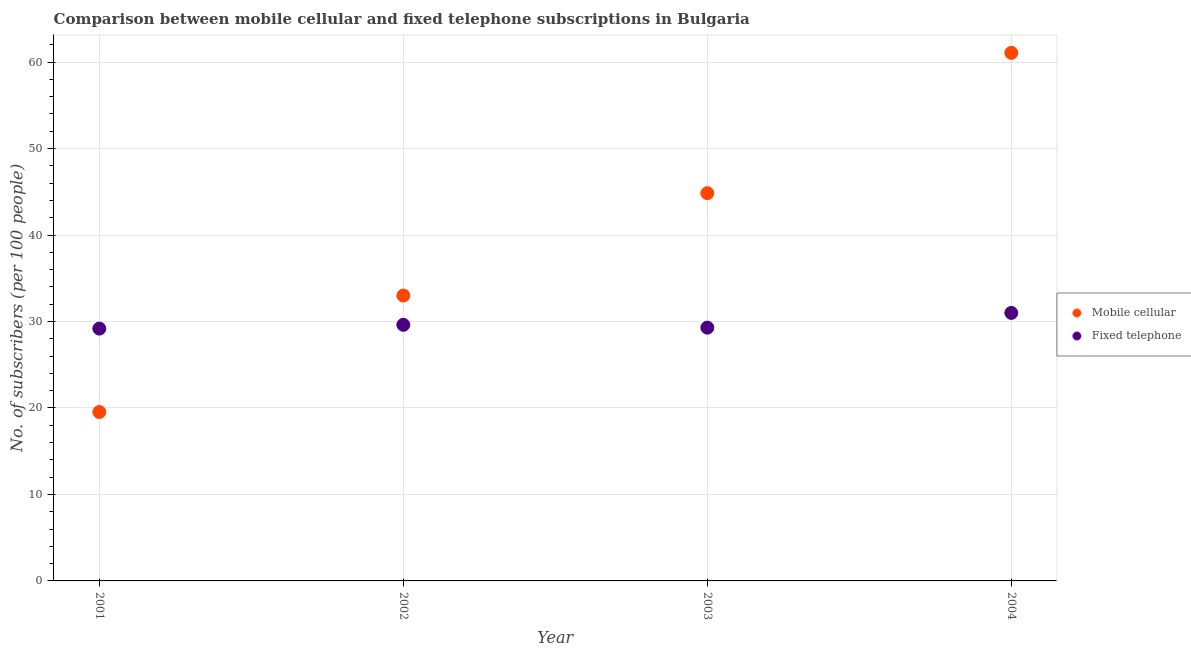How many different coloured dotlines are there?
Keep it short and to the point. 2. Is the number of dotlines equal to the number of legend labels?
Give a very brief answer. Yes. What is the number of fixed telephone subscribers in 2002?
Give a very brief answer. 29.62. Across all years, what is the maximum number of fixed telephone subscribers?
Your answer should be compact. 30.99. Across all years, what is the minimum number of mobile cellular subscribers?
Make the answer very short. 19.53. In which year was the number of mobile cellular subscribers maximum?
Provide a short and direct response. 2004. What is the total number of fixed telephone subscribers in the graph?
Give a very brief answer. 119.08. What is the difference between the number of fixed telephone subscribers in 2001 and that in 2004?
Your response must be concise. -1.81. What is the difference between the number of mobile cellular subscribers in 2002 and the number of fixed telephone subscribers in 2004?
Your answer should be very brief. 2.01. What is the average number of mobile cellular subscribers per year?
Your response must be concise. 39.61. In the year 2001, what is the difference between the number of mobile cellular subscribers and number of fixed telephone subscribers?
Provide a short and direct response. -9.65. What is the ratio of the number of fixed telephone subscribers in 2001 to that in 2003?
Keep it short and to the point. 1. Is the number of mobile cellular subscribers in 2001 less than that in 2002?
Your answer should be compact. Yes. Is the difference between the number of fixed telephone subscribers in 2003 and 2004 greater than the difference between the number of mobile cellular subscribers in 2003 and 2004?
Make the answer very short. Yes. What is the difference between the highest and the second highest number of fixed telephone subscribers?
Your answer should be compact. 1.38. What is the difference between the highest and the lowest number of mobile cellular subscribers?
Your answer should be very brief. 41.54. Is the sum of the number of fixed telephone subscribers in 2001 and 2003 greater than the maximum number of mobile cellular subscribers across all years?
Your response must be concise. No. Does the number of mobile cellular subscribers monotonically increase over the years?
Offer a terse response. Yes. Is the number of mobile cellular subscribers strictly greater than the number of fixed telephone subscribers over the years?
Keep it short and to the point. No. Is the number of mobile cellular subscribers strictly less than the number of fixed telephone subscribers over the years?
Give a very brief answer. No. What is the difference between two consecutive major ticks on the Y-axis?
Your response must be concise. 10. Does the graph contain any zero values?
Provide a succinct answer. No. Does the graph contain grids?
Your response must be concise. Yes. How many legend labels are there?
Your answer should be very brief. 2. What is the title of the graph?
Provide a short and direct response. Comparison between mobile cellular and fixed telephone subscriptions in Bulgaria. What is the label or title of the X-axis?
Your answer should be very brief. Year. What is the label or title of the Y-axis?
Give a very brief answer. No. of subscribers (per 100 people). What is the No. of subscribers (per 100 people) in Mobile cellular in 2001?
Offer a very short reply. 19.53. What is the No. of subscribers (per 100 people) in Fixed telephone in 2001?
Make the answer very short. 29.18. What is the No. of subscribers (per 100 people) of Mobile cellular in 2002?
Ensure brevity in your answer.  33. What is the No. of subscribers (per 100 people) of Fixed telephone in 2002?
Keep it short and to the point. 29.62. What is the No. of subscribers (per 100 people) of Mobile cellular in 2003?
Make the answer very short. 44.84. What is the No. of subscribers (per 100 people) in Fixed telephone in 2003?
Make the answer very short. 29.29. What is the No. of subscribers (per 100 people) in Mobile cellular in 2004?
Ensure brevity in your answer.  61.07. What is the No. of subscribers (per 100 people) in Fixed telephone in 2004?
Keep it short and to the point. 30.99. Across all years, what is the maximum No. of subscribers (per 100 people) in Mobile cellular?
Offer a terse response. 61.07. Across all years, what is the maximum No. of subscribers (per 100 people) in Fixed telephone?
Your answer should be compact. 30.99. Across all years, what is the minimum No. of subscribers (per 100 people) in Mobile cellular?
Make the answer very short. 19.53. Across all years, what is the minimum No. of subscribers (per 100 people) in Fixed telephone?
Make the answer very short. 29.18. What is the total No. of subscribers (per 100 people) in Mobile cellular in the graph?
Give a very brief answer. 158.45. What is the total No. of subscribers (per 100 people) in Fixed telephone in the graph?
Provide a short and direct response. 119.08. What is the difference between the No. of subscribers (per 100 people) in Mobile cellular in 2001 and that in 2002?
Make the answer very short. -13.47. What is the difference between the No. of subscribers (per 100 people) of Fixed telephone in 2001 and that in 2002?
Offer a very short reply. -0.44. What is the difference between the No. of subscribers (per 100 people) in Mobile cellular in 2001 and that in 2003?
Your answer should be compact. -25.31. What is the difference between the No. of subscribers (per 100 people) in Fixed telephone in 2001 and that in 2003?
Offer a terse response. -0.11. What is the difference between the No. of subscribers (per 100 people) of Mobile cellular in 2001 and that in 2004?
Offer a very short reply. -41.54. What is the difference between the No. of subscribers (per 100 people) in Fixed telephone in 2001 and that in 2004?
Your answer should be compact. -1.81. What is the difference between the No. of subscribers (per 100 people) in Mobile cellular in 2002 and that in 2003?
Offer a very short reply. -11.84. What is the difference between the No. of subscribers (per 100 people) in Fixed telephone in 2002 and that in 2003?
Keep it short and to the point. 0.33. What is the difference between the No. of subscribers (per 100 people) in Mobile cellular in 2002 and that in 2004?
Ensure brevity in your answer.  -28.07. What is the difference between the No. of subscribers (per 100 people) in Fixed telephone in 2002 and that in 2004?
Give a very brief answer. -1.38. What is the difference between the No. of subscribers (per 100 people) in Mobile cellular in 2003 and that in 2004?
Ensure brevity in your answer.  -16.23. What is the difference between the No. of subscribers (per 100 people) in Fixed telephone in 2003 and that in 2004?
Keep it short and to the point. -1.7. What is the difference between the No. of subscribers (per 100 people) in Mobile cellular in 2001 and the No. of subscribers (per 100 people) in Fixed telephone in 2002?
Your response must be concise. -10.08. What is the difference between the No. of subscribers (per 100 people) in Mobile cellular in 2001 and the No. of subscribers (per 100 people) in Fixed telephone in 2003?
Your answer should be very brief. -9.76. What is the difference between the No. of subscribers (per 100 people) of Mobile cellular in 2001 and the No. of subscribers (per 100 people) of Fixed telephone in 2004?
Your response must be concise. -11.46. What is the difference between the No. of subscribers (per 100 people) in Mobile cellular in 2002 and the No. of subscribers (per 100 people) in Fixed telephone in 2003?
Your answer should be compact. 3.71. What is the difference between the No. of subscribers (per 100 people) in Mobile cellular in 2002 and the No. of subscribers (per 100 people) in Fixed telephone in 2004?
Your response must be concise. 2.01. What is the difference between the No. of subscribers (per 100 people) in Mobile cellular in 2003 and the No. of subscribers (per 100 people) in Fixed telephone in 2004?
Keep it short and to the point. 13.85. What is the average No. of subscribers (per 100 people) in Mobile cellular per year?
Your answer should be compact. 39.61. What is the average No. of subscribers (per 100 people) of Fixed telephone per year?
Ensure brevity in your answer.  29.77. In the year 2001, what is the difference between the No. of subscribers (per 100 people) of Mobile cellular and No. of subscribers (per 100 people) of Fixed telephone?
Offer a very short reply. -9.65. In the year 2002, what is the difference between the No. of subscribers (per 100 people) in Mobile cellular and No. of subscribers (per 100 people) in Fixed telephone?
Keep it short and to the point. 3.39. In the year 2003, what is the difference between the No. of subscribers (per 100 people) in Mobile cellular and No. of subscribers (per 100 people) in Fixed telephone?
Your response must be concise. 15.55. In the year 2004, what is the difference between the No. of subscribers (per 100 people) of Mobile cellular and No. of subscribers (per 100 people) of Fixed telephone?
Provide a succinct answer. 30.08. What is the ratio of the No. of subscribers (per 100 people) of Mobile cellular in 2001 to that in 2002?
Your answer should be compact. 0.59. What is the ratio of the No. of subscribers (per 100 people) of Fixed telephone in 2001 to that in 2002?
Provide a short and direct response. 0.99. What is the ratio of the No. of subscribers (per 100 people) of Mobile cellular in 2001 to that in 2003?
Your answer should be compact. 0.44. What is the ratio of the No. of subscribers (per 100 people) in Mobile cellular in 2001 to that in 2004?
Keep it short and to the point. 0.32. What is the ratio of the No. of subscribers (per 100 people) in Fixed telephone in 2001 to that in 2004?
Your response must be concise. 0.94. What is the ratio of the No. of subscribers (per 100 people) in Mobile cellular in 2002 to that in 2003?
Offer a very short reply. 0.74. What is the ratio of the No. of subscribers (per 100 people) in Fixed telephone in 2002 to that in 2003?
Your response must be concise. 1.01. What is the ratio of the No. of subscribers (per 100 people) in Mobile cellular in 2002 to that in 2004?
Offer a very short reply. 0.54. What is the ratio of the No. of subscribers (per 100 people) of Fixed telephone in 2002 to that in 2004?
Offer a terse response. 0.96. What is the ratio of the No. of subscribers (per 100 people) of Mobile cellular in 2003 to that in 2004?
Your answer should be very brief. 0.73. What is the ratio of the No. of subscribers (per 100 people) in Fixed telephone in 2003 to that in 2004?
Make the answer very short. 0.94. What is the difference between the highest and the second highest No. of subscribers (per 100 people) of Mobile cellular?
Provide a succinct answer. 16.23. What is the difference between the highest and the second highest No. of subscribers (per 100 people) in Fixed telephone?
Ensure brevity in your answer.  1.38. What is the difference between the highest and the lowest No. of subscribers (per 100 people) of Mobile cellular?
Your answer should be very brief. 41.54. What is the difference between the highest and the lowest No. of subscribers (per 100 people) of Fixed telephone?
Provide a short and direct response. 1.81. 